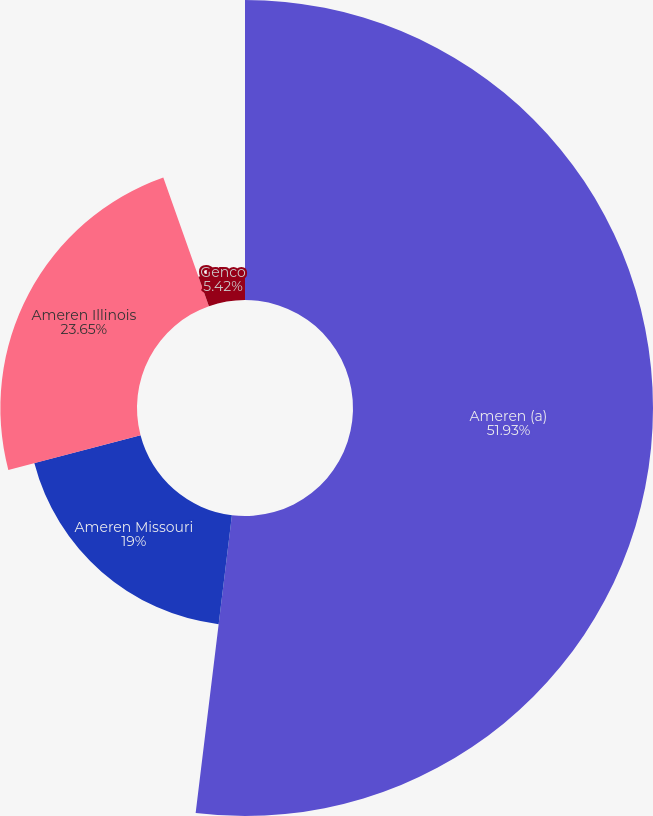Convert chart to OTSL. <chart><loc_0><loc_0><loc_500><loc_500><pie_chart><fcel>Ameren (a)<fcel>Ameren Missouri<fcel>Ameren Illinois<fcel>Genco<nl><fcel>51.93%<fcel>19.0%<fcel>23.65%<fcel>5.42%<nl></chart> 